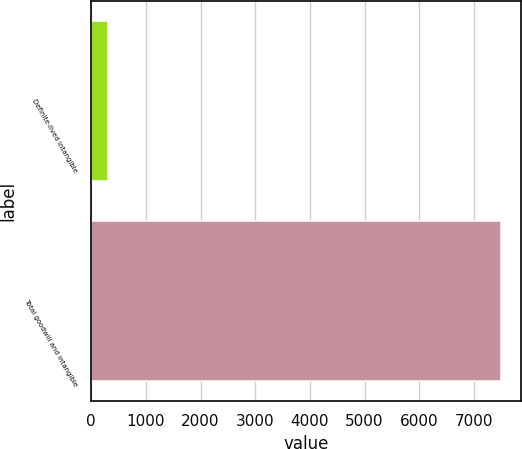Convert chart. <chart><loc_0><loc_0><loc_500><loc_500><bar_chart><fcel>Definite-lived intangible<fcel>Total goodwill and intangible<nl><fcel>311.3<fcel>7486.1<nl></chart> 